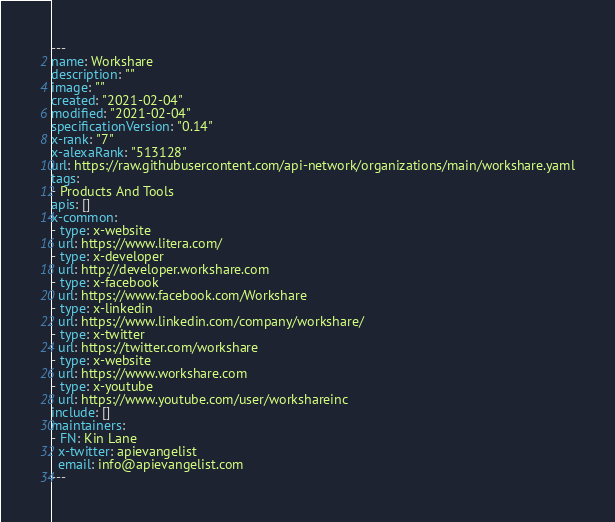Convert code to text. <code><loc_0><loc_0><loc_500><loc_500><_YAML_>---
name: Workshare
description: ""
image: ""
created: "2021-02-04"
modified: "2021-02-04"
specificationVersion: "0.14"
x-rank: "7"
x-alexaRank: "513128"
url: https://raw.githubusercontent.com/api-network/organizations/main/workshare.yaml
tags:
- Products And Tools
apis: []
x-common:
- type: x-website
  url: https://www.litera.com/
- type: x-developer
  url: http://developer.workshare.com
- type: x-facebook
  url: https://www.facebook.com/Workshare
- type: x-linkedin
  url: https://www.linkedin.com/company/workshare/
- type: x-twitter
  url: https://twitter.com/workshare
- type: x-website
  url: https://www.workshare.com
- type: x-youtube
  url: https://www.youtube.com/user/workshareinc
include: []
maintainers:
- FN: Kin Lane
  x-twitter: apievangelist
  email: info@apievangelist.com
---</code> 